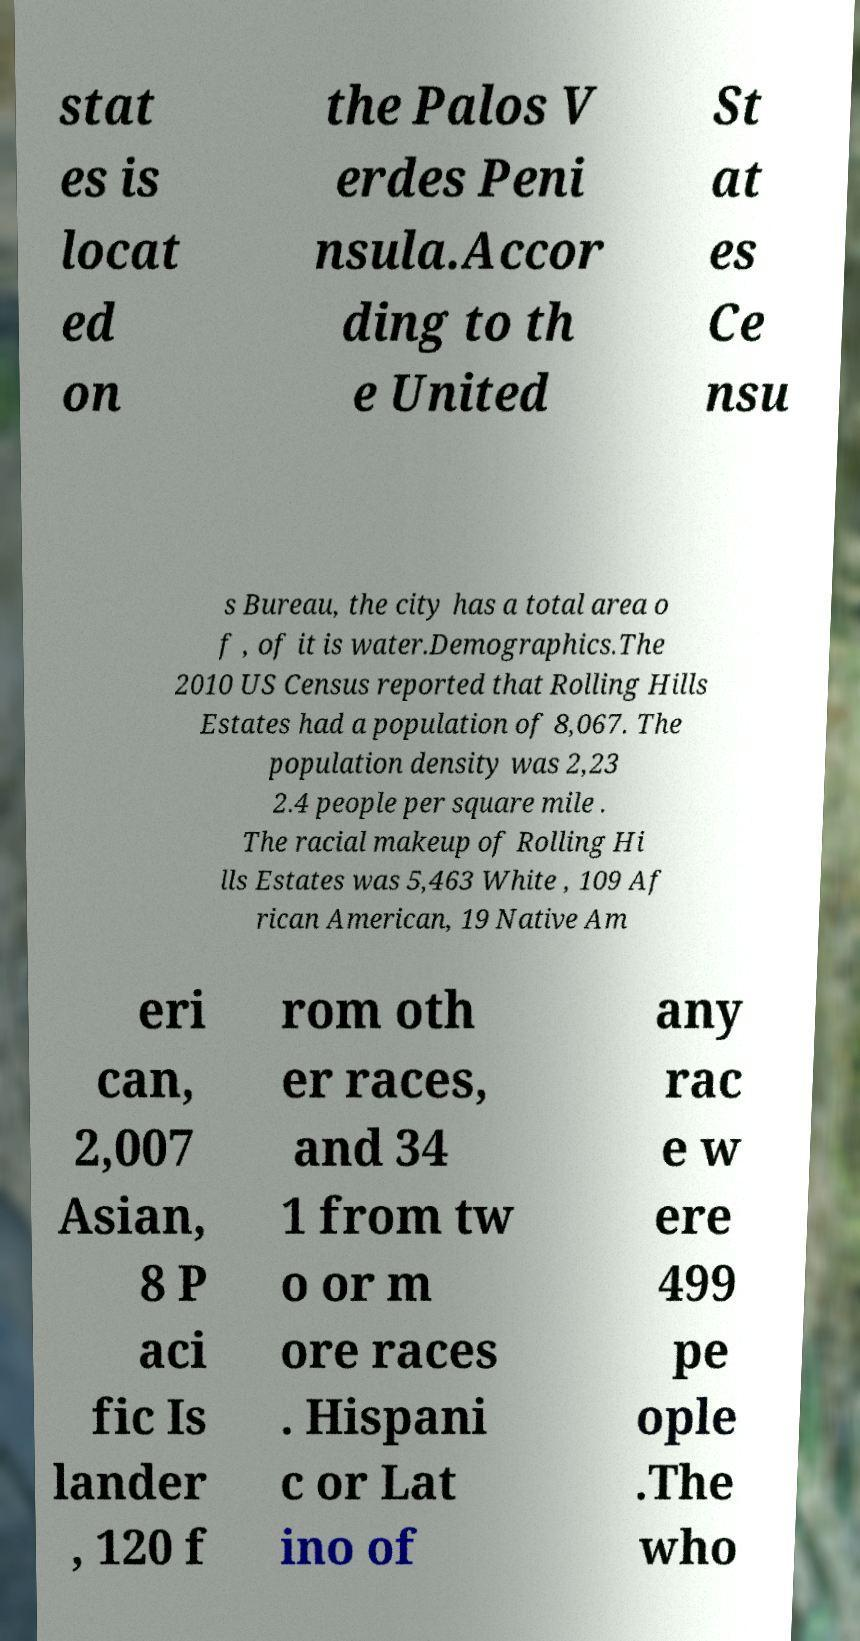Could you extract and type out the text from this image? stat es is locat ed on the Palos V erdes Peni nsula.Accor ding to th e United St at es Ce nsu s Bureau, the city has a total area o f , of it is water.Demographics.The 2010 US Census reported that Rolling Hills Estates had a population of 8,067. The population density was 2,23 2.4 people per square mile . The racial makeup of Rolling Hi lls Estates was 5,463 White , 109 Af rican American, 19 Native Am eri can, 2,007 Asian, 8 P aci fic Is lander , 120 f rom oth er races, and 34 1 from tw o or m ore races . Hispani c or Lat ino of any rac e w ere 499 pe ople .The who 